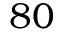Convert formula to latex. <formula><loc_0><loc_0><loc_500><loc_500>8 0</formula> 